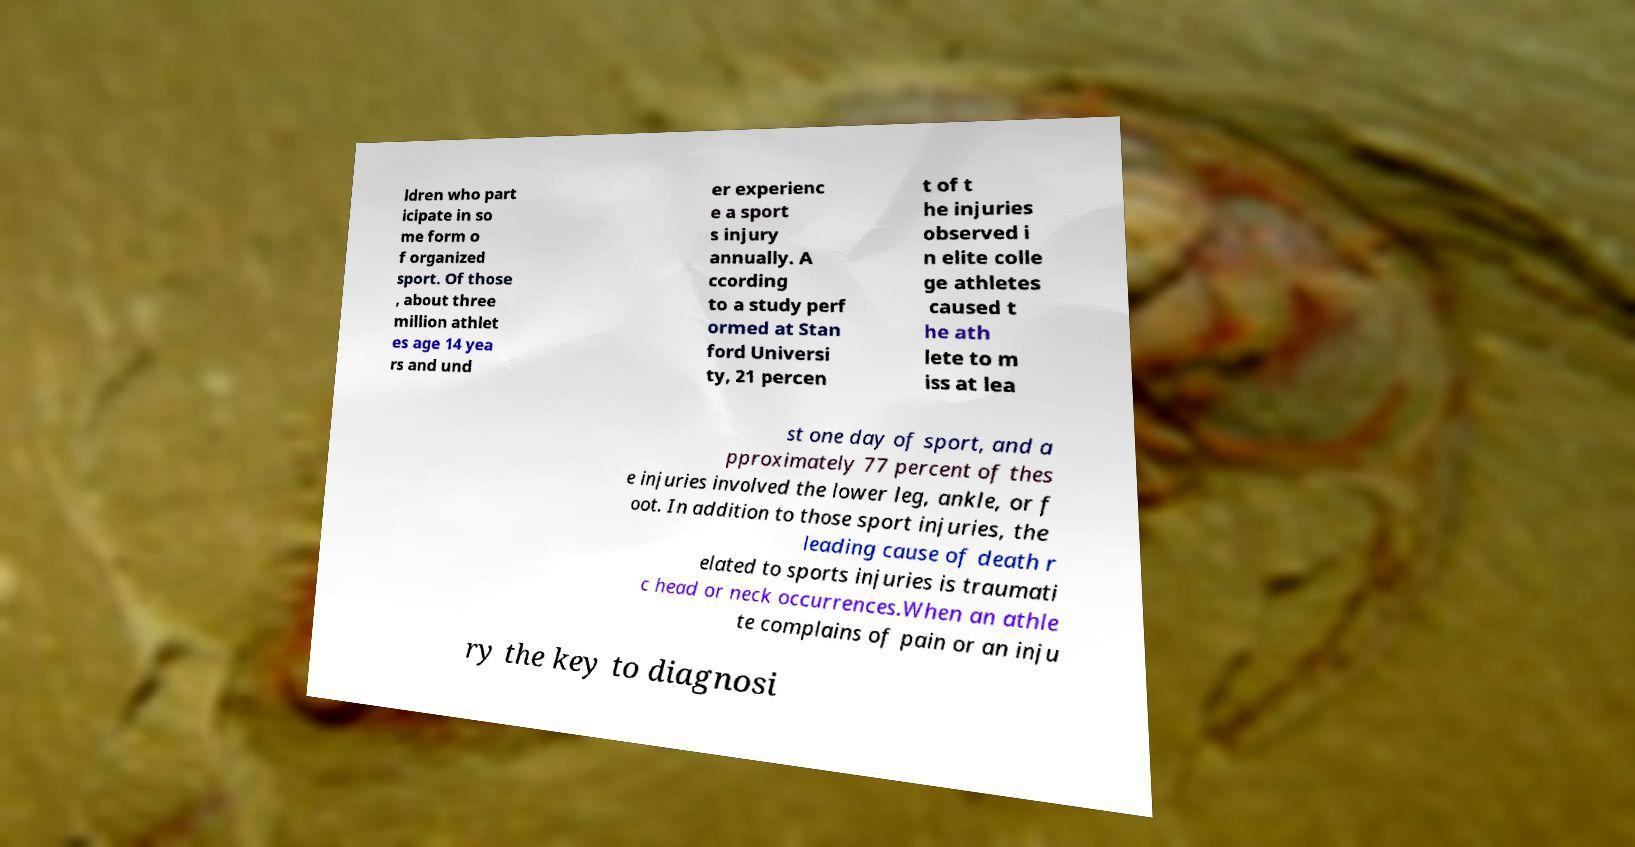There's text embedded in this image that I need extracted. Can you transcribe it verbatim? ldren who part icipate in so me form o f organized sport. Of those , about three million athlet es age 14 yea rs and und er experienc e a sport s injury annually. A ccording to a study perf ormed at Stan ford Universi ty, 21 percen t of t he injuries observed i n elite colle ge athletes caused t he ath lete to m iss at lea st one day of sport, and a pproximately 77 percent of thes e injuries involved the lower leg, ankle, or f oot. In addition to those sport injuries, the leading cause of death r elated to sports injuries is traumati c head or neck occurrences.When an athle te complains of pain or an inju ry the key to diagnosi 